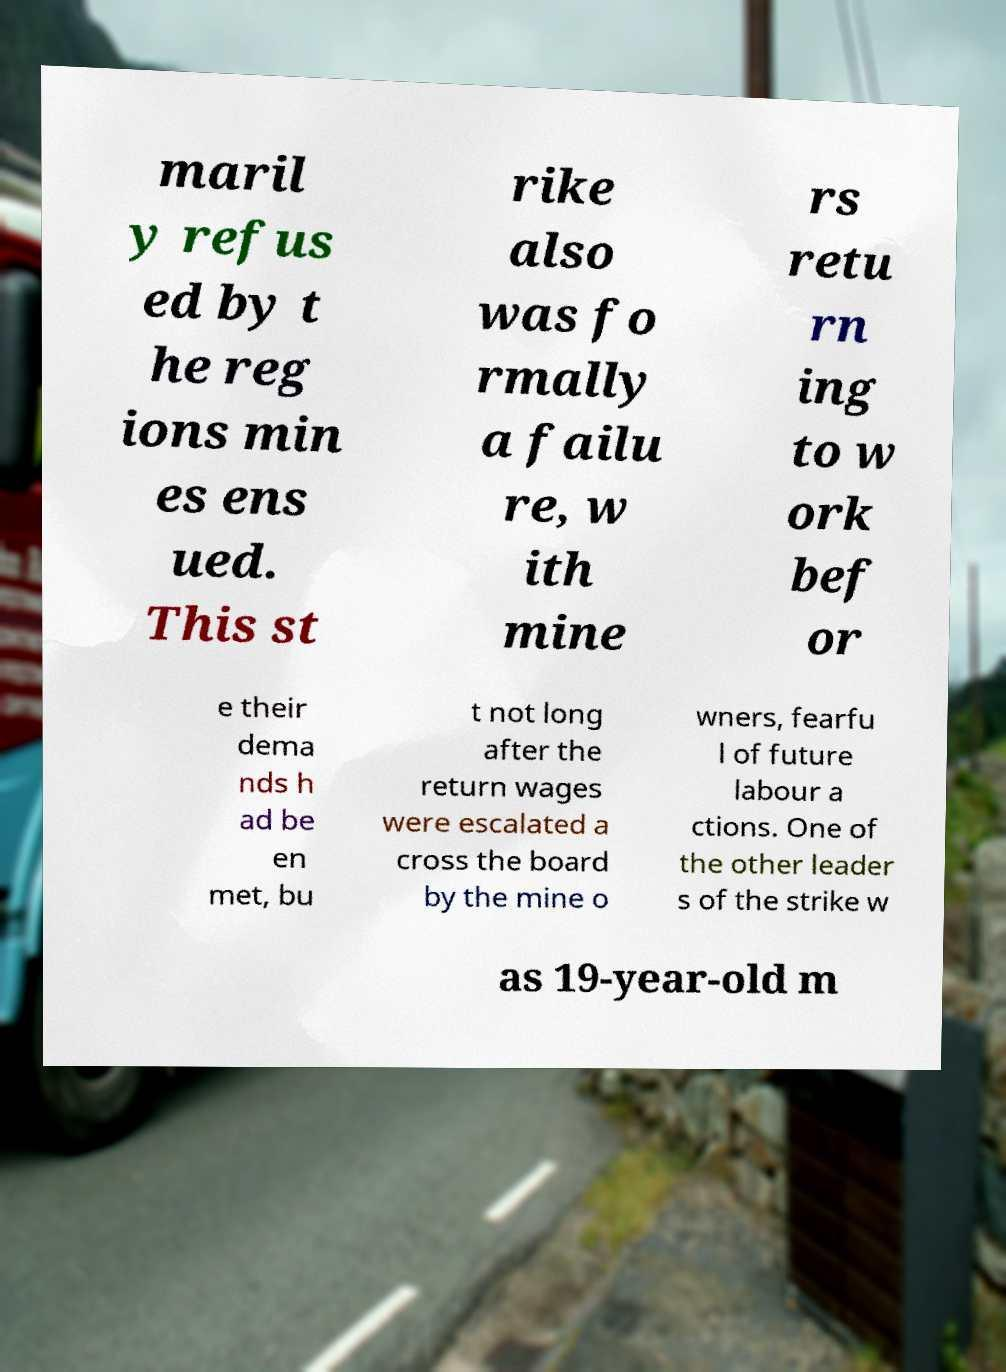For documentation purposes, I need the text within this image transcribed. Could you provide that? maril y refus ed by t he reg ions min es ens ued. This st rike also was fo rmally a failu re, w ith mine rs retu rn ing to w ork bef or e their dema nds h ad be en met, bu t not long after the return wages were escalated a cross the board by the mine o wners, fearfu l of future labour a ctions. One of the other leader s of the strike w as 19-year-old m 